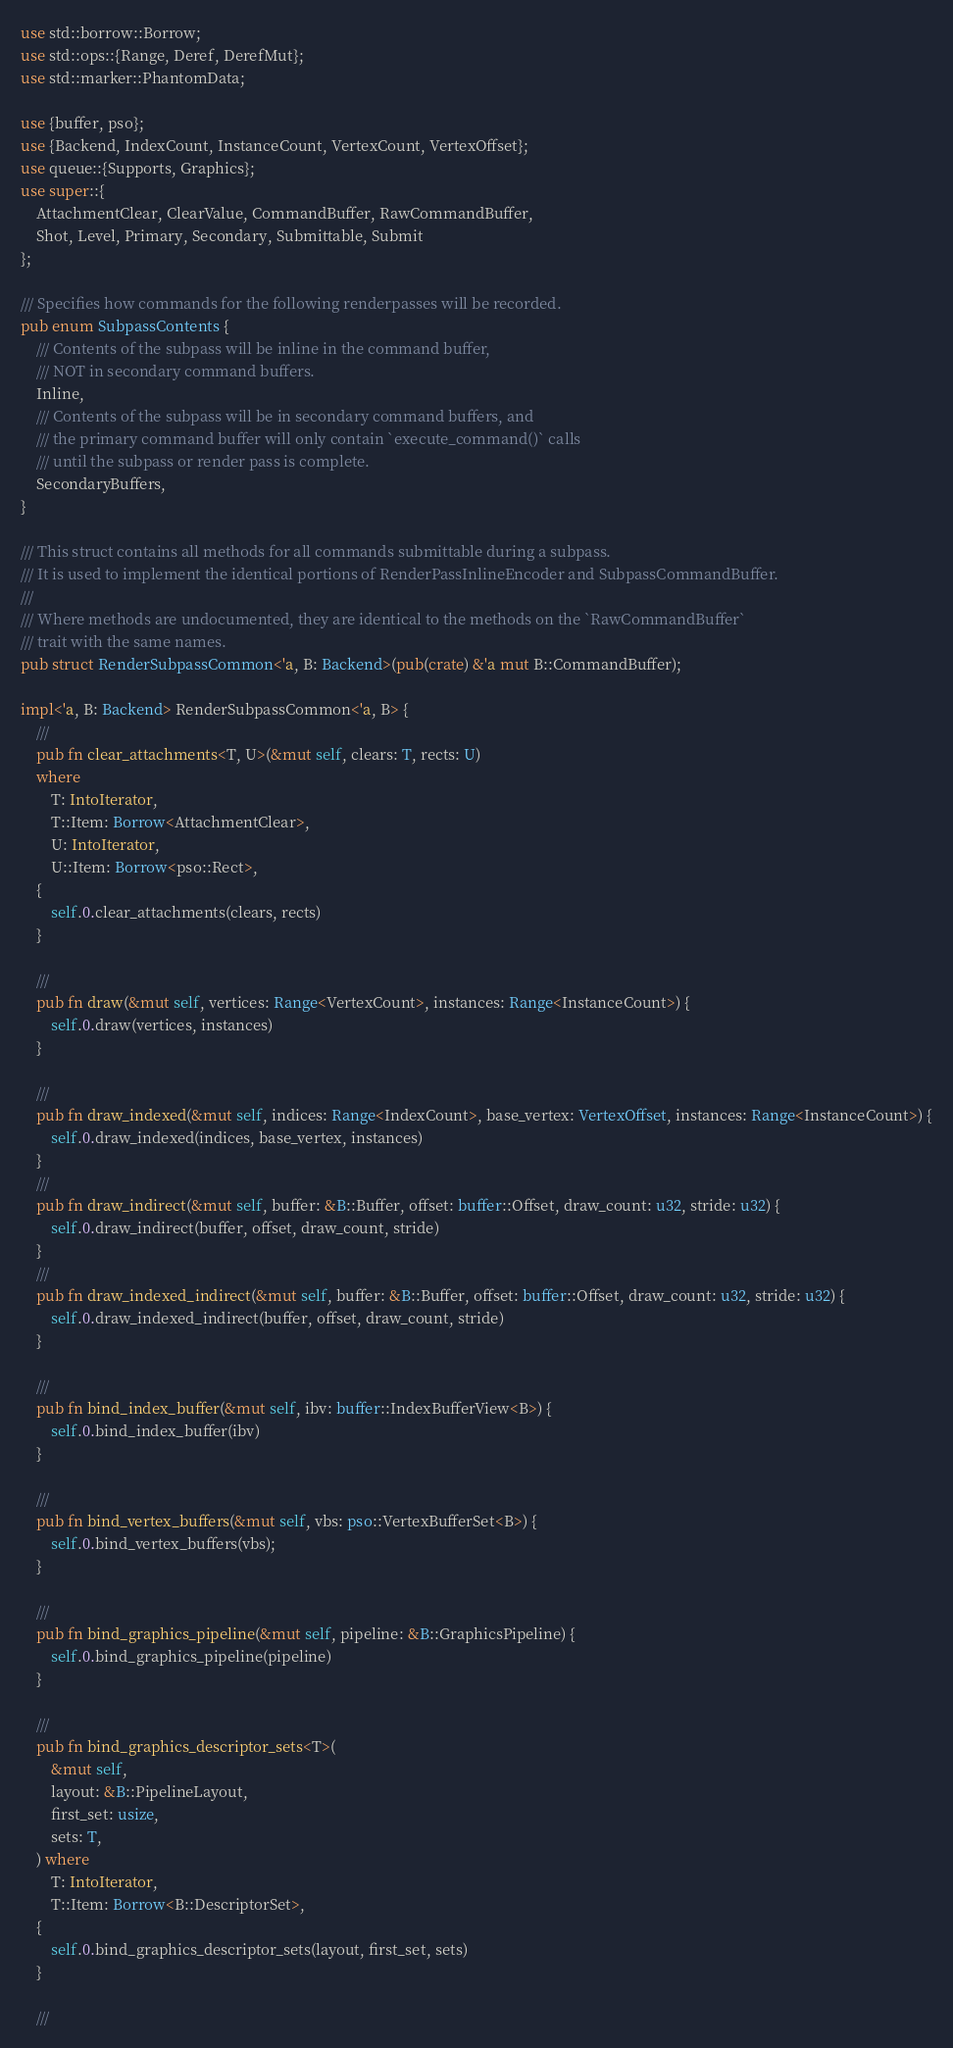Convert code to text. <code><loc_0><loc_0><loc_500><loc_500><_Rust_>use std::borrow::Borrow;
use std::ops::{Range, Deref, DerefMut};
use std::marker::PhantomData;

use {buffer, pso};
use {Backend, IndexCount, InstanceCount, VertexCount, VertexOffset};
use queue::{Supports, Graphics};
use super::{
    AttachmentClear, ClearValue, CommandBuffer, RawCommandBuffer,
    Shot, Level, Primary, Secondary, Submittable, Submit
};

/// Specifies how commands for the following renderpasses will be recorded.
pub enum SubpassContents {
    /// Contents of the subpass will be inline in the command buffer,
    /// NOT in secondary command buffers.
    Inline,
    /// Contents of the subpass will be in secondary command buffers, and
    /// the primary command buffer will only contain `execute_command()` calls
    /// until the subpass or render pass is complete.
    SecondaryBuffers,
}

/// This struct contains all methods for all commands submittable during a subpass.
/// It is used to implement the identical portions of RenderPassInlineEncoder and SubpassCommandBuffer.
///
/// Where methods are undocumented, they are identical to the methods on the `RawCommandBuffer`
/// trait with the same names.
pub struct RenderSubpassCommon<'a, B: Backend>(pub(crate) &'a mut B::CommandBuffer);

impl<'a, B: Backend> RenderSubpassCommon<'a, B> {
    ///
    pub fn clear_attachments<T, U>(&mut self, clears: T, rects: U)
    where
        T: IntoIterator,
        T::Item: Borrow<AttachmentClear>,
        U: IntoIterator,
        U::Item: Borrow<pso::Rect>,
    {
        self.0.clear_attachments(clears, rects)
    }

    ///
    pub fn draw(&mut self, vertices: Range<VertexCount>, instances: Range<InstanceCount>) {
        self.0.draw(vertices, instances)
    }

    ///
    pub fn draw_indexed(&mut self, indices: Range<IndexCount>, base_vertex: VertexOffset, instances: Range<InstanceCount>) {
        self.0.draw_indexed(indices, base_vertex, instances)
    }
    ///
    pub fn draw_indirect(&mut self, buffer: &B::Buffer, offset: buffer::Offset, draw_count: u32, stride: u32) {
        self.0.draw_indirect(buffer, offset, draw_count, stride)
    }
    ///
    pub fn draw_indexed_indirect(&mut self, buffer: &B::Buffer, offset: buffer::Offset, draw_count: u32, stride: u32) {
        self.0.draw_indexed_indirect(buffer, offset, draw_count, stride)
    }

    ///
    pub fn bind_index_buffer(&mut self, ibv: buffer::IndexBufferView<B>) {
        self.0.bind_index_buffer(ibv)
    }

    ///
    pub fn bind_vertex_buffers(&mut self, vbs: pso::VertexBufferSet<B>) {
        self.0.bind_vertex_buffers(vbs);
    }

    ///
    pub fn bind_graphics_pipeline(&mut self, pipeline: &B::GraphicsPipeline) {
        self.0.bind_graphics_pipeline(pipeline)
    }

    ///
    pub fn bind_graphics_descriptor_sets<T>(
        &mut self,
        layout: &B::PipelineLayout,
        first_set: usize,
        sets: T,
    ) where
        T: IntoIterator,
        T::Item: Borrow<B::DescriptorSet>,
    {
        self.0.bind_graphics_descriptor_sets(layout, first_set, sets)
    }

    ///</code> 